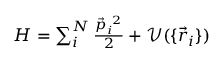<formula> <loc_0><loc_0><loc_500><loc_500>\begin{array} { r } { H = \sum _ { i } ^ { N } \frac { \vec { p } _ { i } ^ { 2 } } { 2 } + \mathcal { V } ( \{ \vec { r } _ { i } \} ) } \end{array}</formula> 